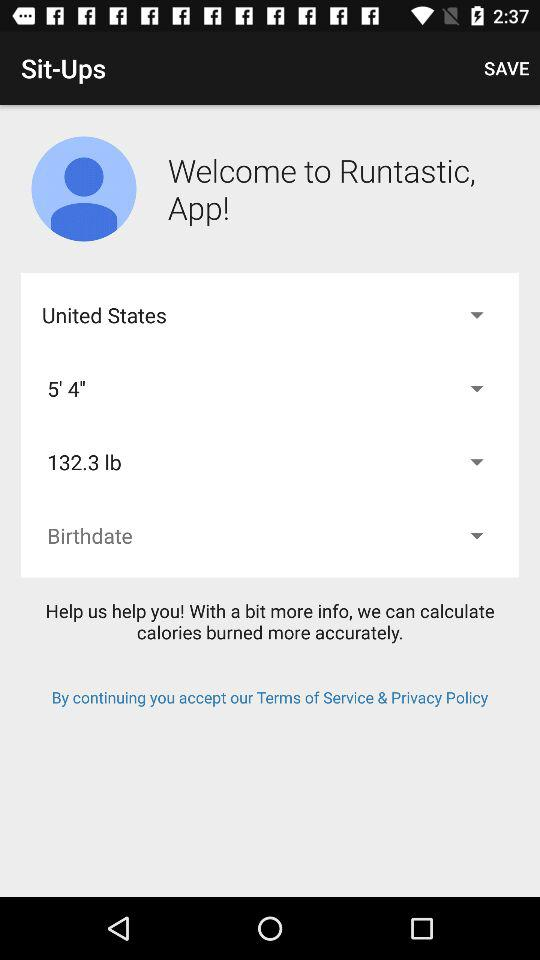Which country is selected? The selected country is the United States. 